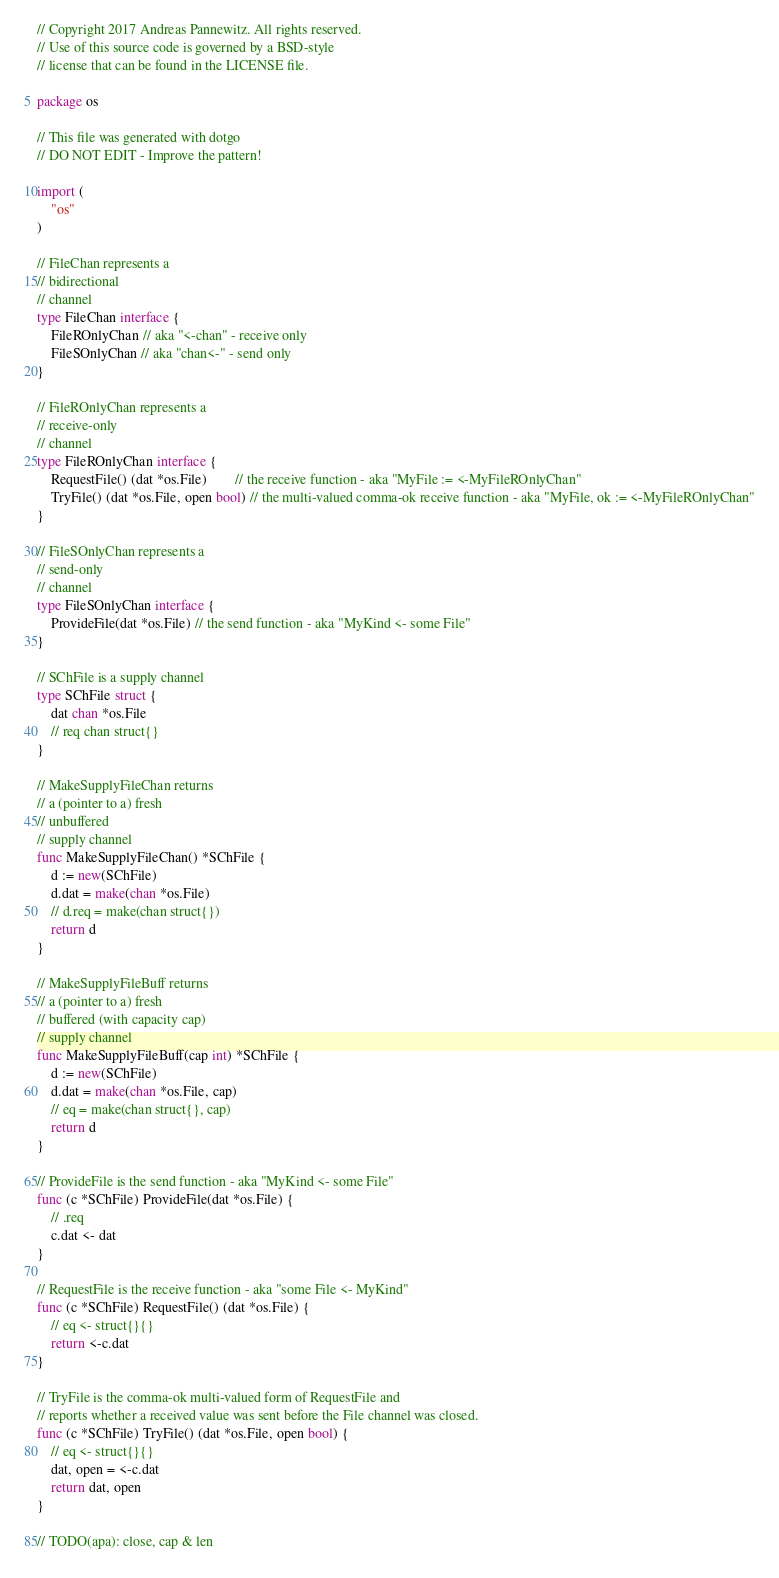Convert code to text. <code><loc_0><loc_0><loc_500><loc_500><_Go_>// Copyright 2017 Andreas Pannewitz. All rights reserved.
// Use of this source code is governed by a BSD-style
// license that can be found in the LICENSE file.

package os

// This file was generated with dotgo
// DO NOT EDIT - Improve the pattern!

import (
	"os"
)

// FileChan represents a
// bidirectional
// channel
type FileChan interface {
	FileROnlyChan // aka "<-chan" - receive only
	FileSOnlyChan // aka "chan<-" - send only
}

// FileROnlyChan represents a
// receive-only
// channel
type FileROnlyChan interface {
	RequestFile() (dat *os.File)        // the receive function - aka "MyFile := <-MyFileROnlyChan"
	TryFile() (dat *os.File, open bool) // the multi-valued comma-ok receive function - aka "MyFile, ok := <-MyFileROnlyChan"
}

// FileSOnlyChan represents a
// send-only
// channel
type FileSOnlyChan interface {
	ProvideFile(dat *os.File) // the send function - aka "MyKind <- some File"
}

// SChFile is a supply channel
type SChFile struct {
	dat chan *os.File
	// req chan struct{}
}

// MakeSupplyFileChan returns
// a (pointer to a) fresh
// unbuffered
// supply channel
func MakeSupplyFileChan() *SChFile {
	d := new(SChFile)
	d.dat = make(chan *os.File)
	// d.req = make(chan struct{})
	return d
}

// MakeSupplyFileBuff returns
// a (pointer to a) fresh
// buffered (with capacity cap)
// supply channel
func MakeSupplyFileBuff(cap int) *SChFile {
	d := new(SChFile)
	d.dat = make(chan *os.File, cap)
	// eq = make(chan struct{}, cap)
	return d
}

// ProvideFile is the send function - aka "MyKind <- some File"
func (c *SChFile) ProvideFile(dat *os.File) {
	// .req
	c.dat <- dat
}

// RequestFile is the receive function - aka "some File <- MyKind"
func (c *SChFile) RequestFile() (dat *os.File) {
	// eq <- struct{}{}
	return <-c.dat
}

// TryFile is the comma-ok multi-valued form of RequestFile and
// reports whether a received value was sent before the File channel was closed.
func (c *SChFile) TryFile() (dat *os.File, open bool) {
	// eq <- struct{}{}
	dat, open = <-c.dat
	return dat, open
}

// TODO(apa): close, cap & len
</code> 